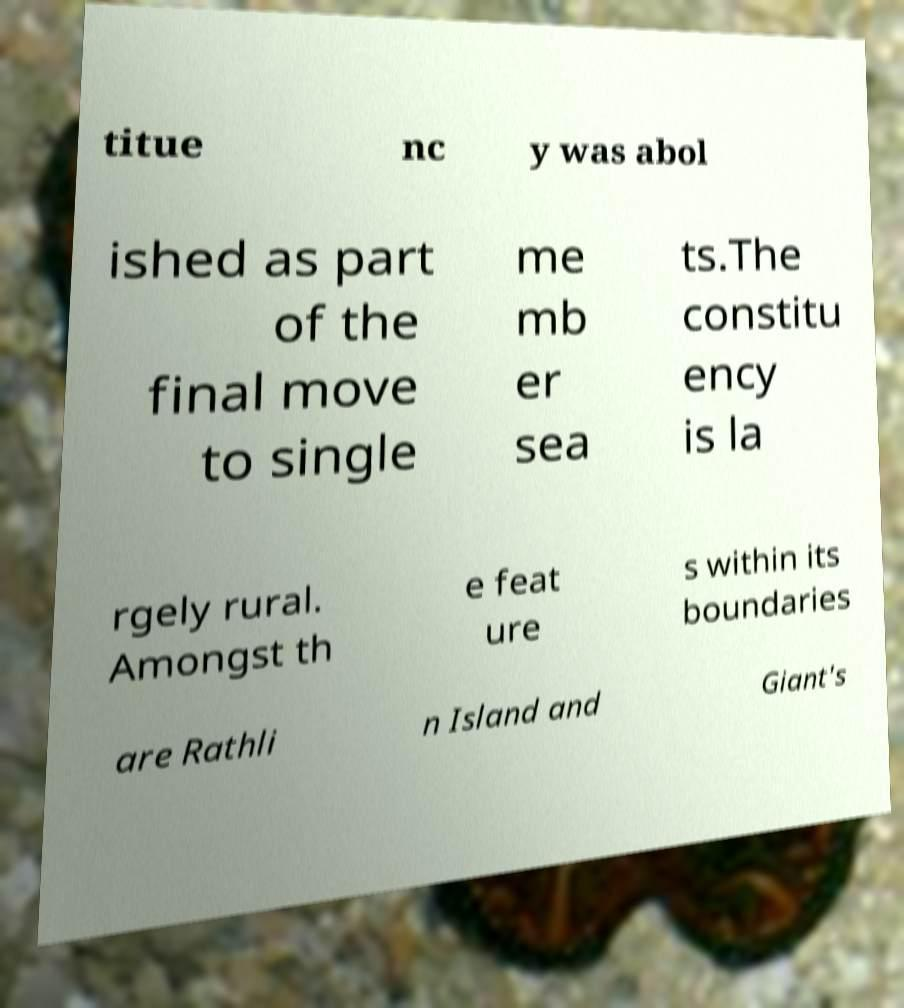Can you accurately transcribe the text from the provided image for me? titue nc y was abol ished as part of the final move to single me mb er sea ts.The constitu ency is la rgely rural. Amongst th e feat ure s within its boundaries are Rathli n Island and Giant's 